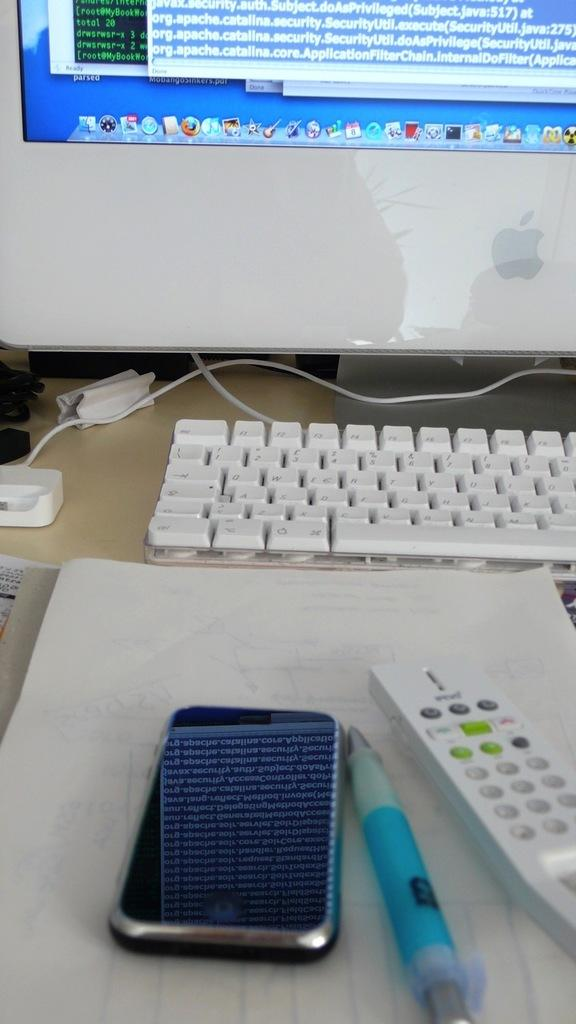<image>
Share a concise interpretation of the image provided. A mac desktop computer that is on a desk. 